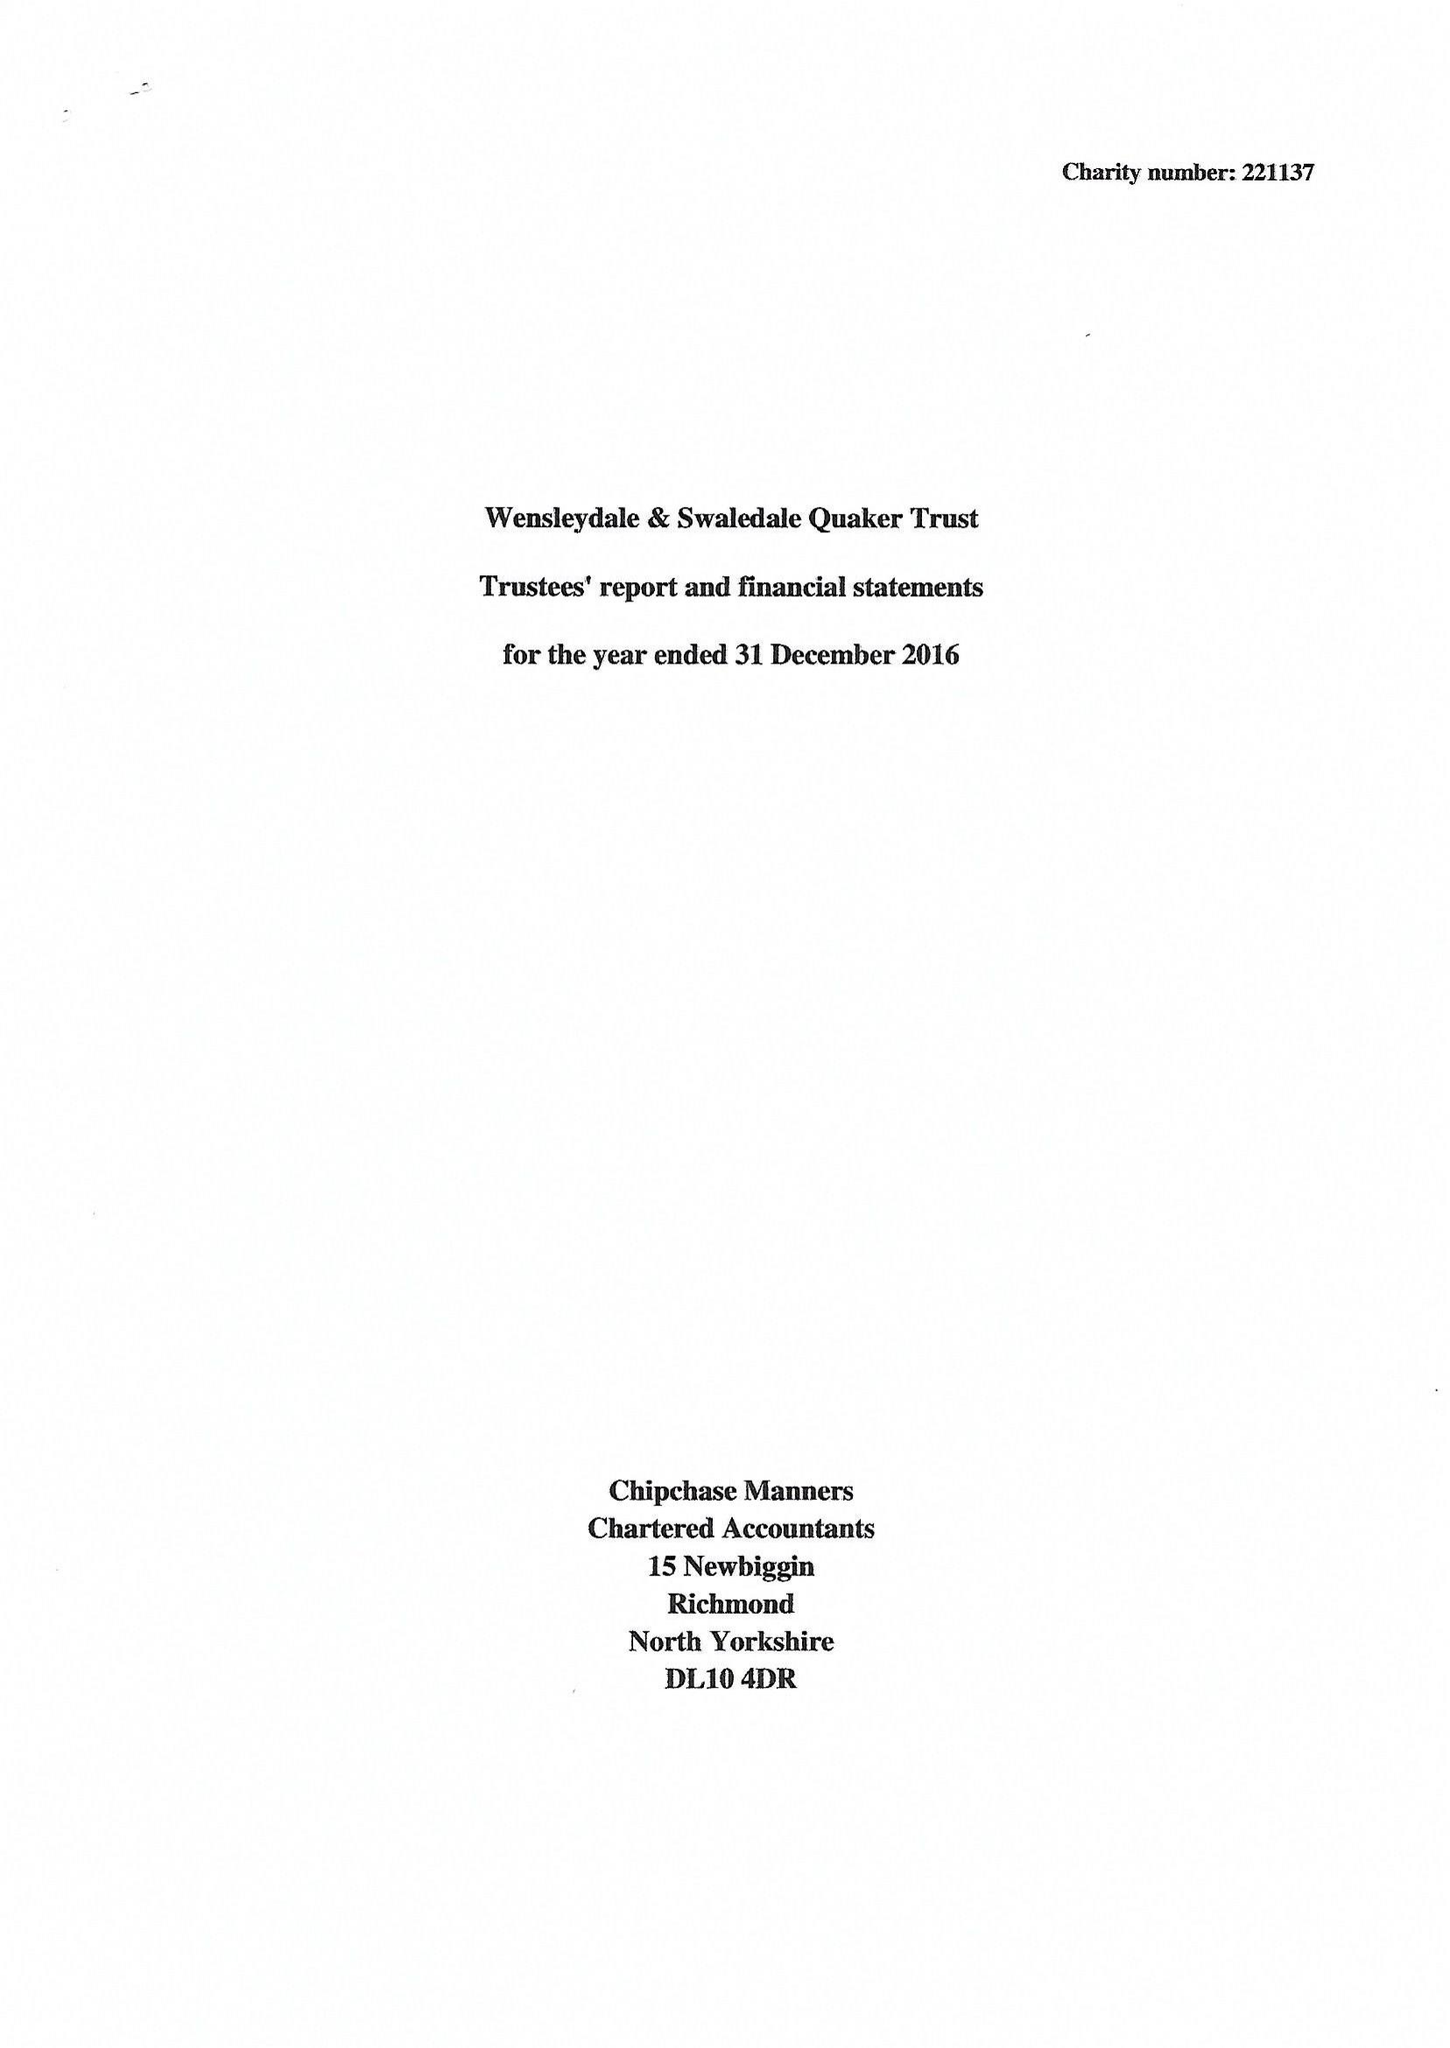What is the value for the spending_annually_in_british_pounds?
Answer the question using a single word or phrase. 62593.00 